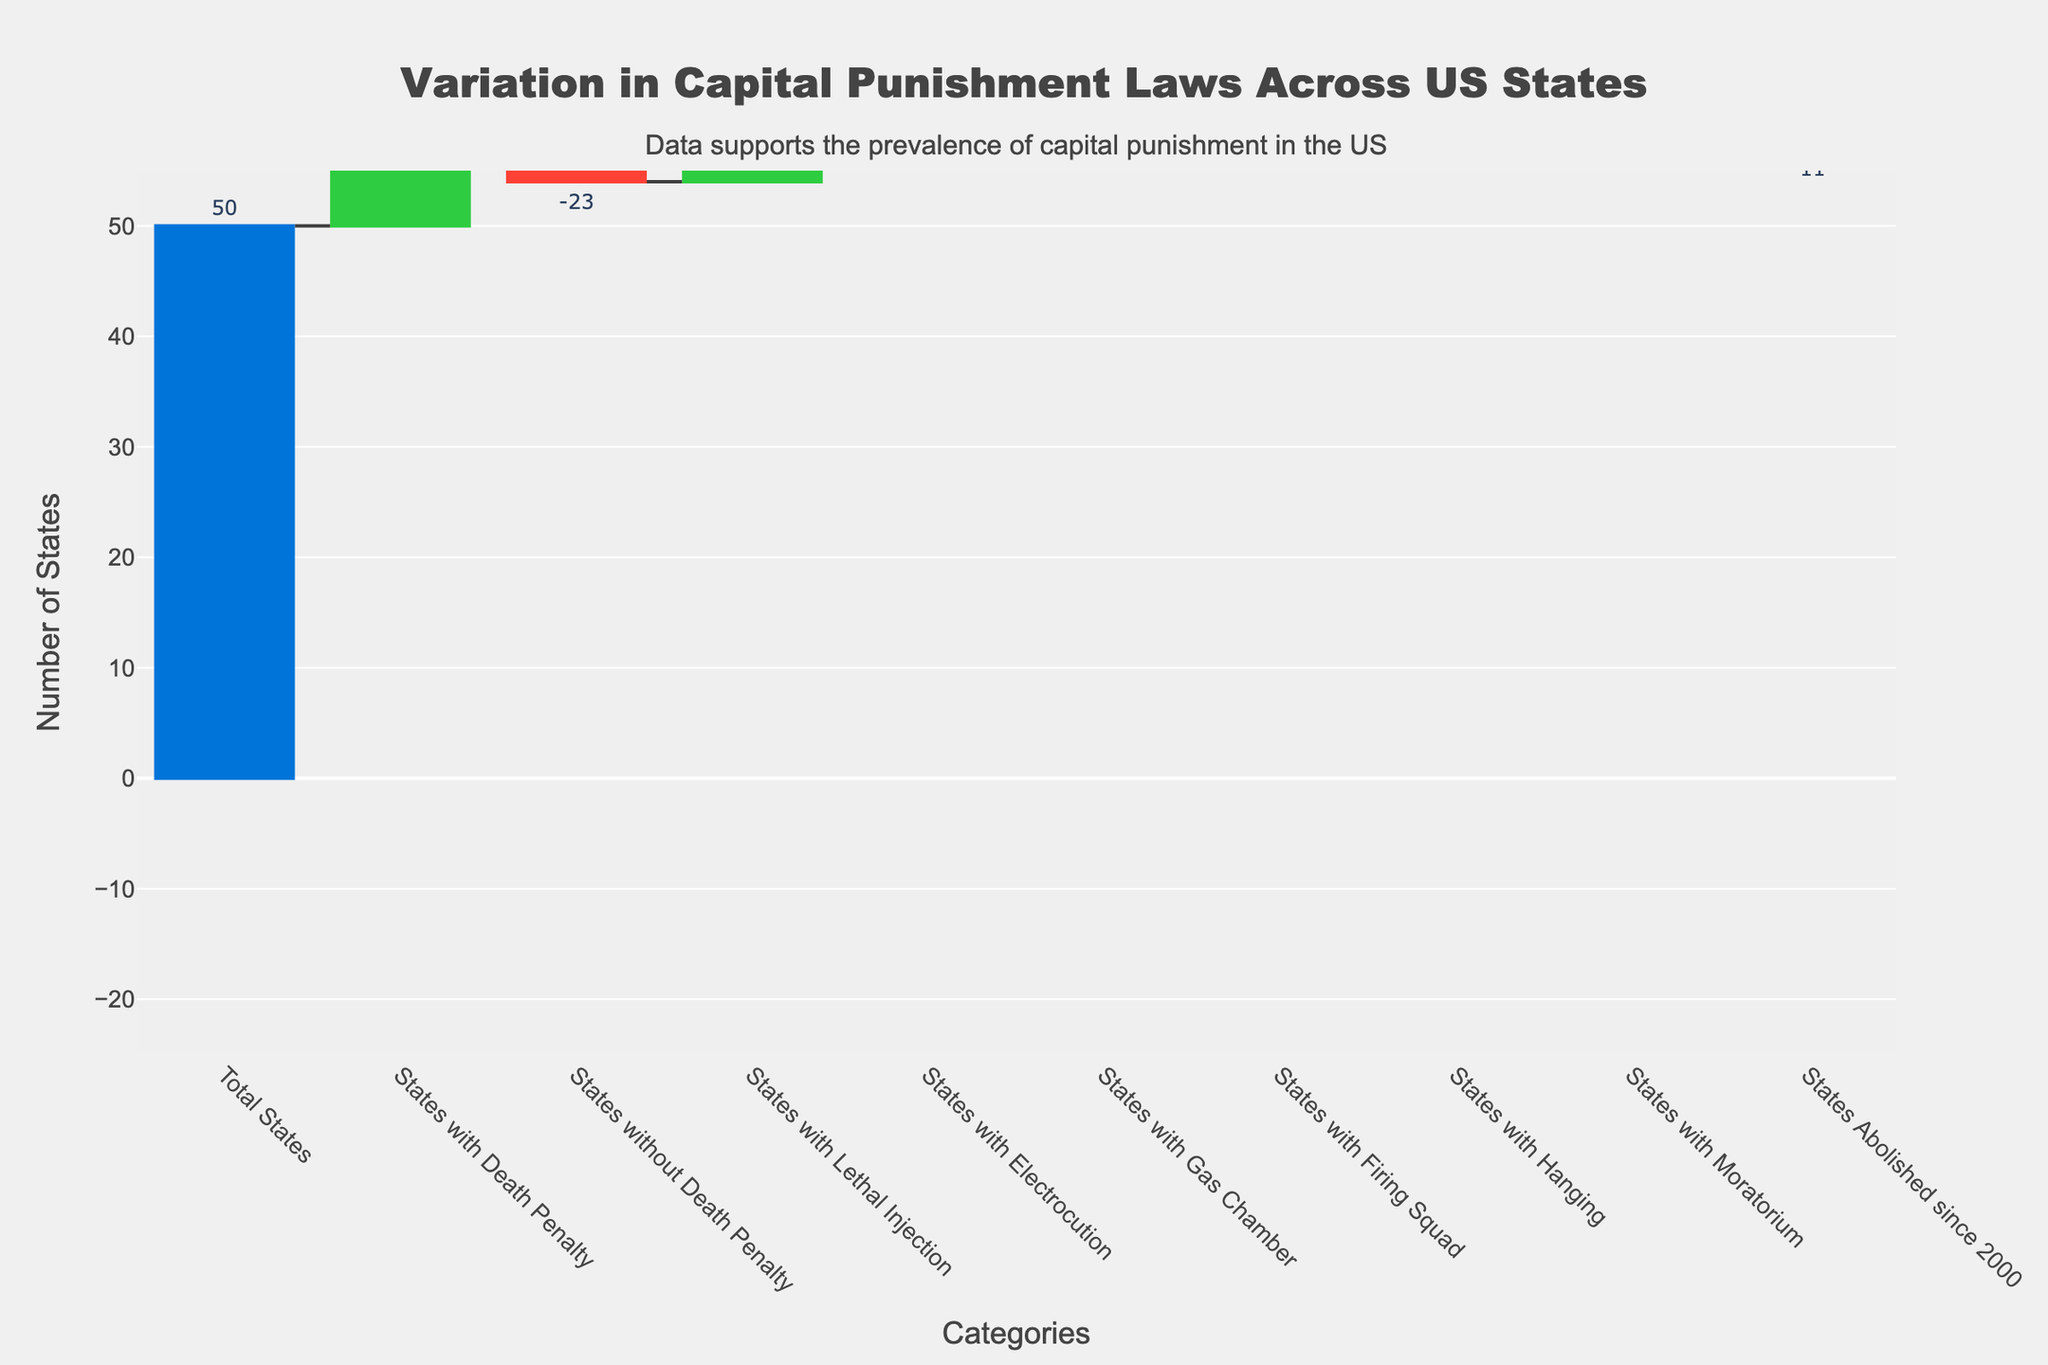What's the total number of states analyzed in the chart? The title and the first category data indicate that the total number of states analyzed is 50.
Answer: 50 How many states have the death penalty? The category "States with Death Penalty" shows a value of 27, which indicates the number of states with the death penalty.
Answer: 27 What's the number of states that do not have the death penalty? The category "States without Death Penalty" shows a negative value of -23, indicating 23 states do not have the death penalty.
Answer: 23 How many states use lethal injection as a method of execution? The category "States with Lethal Injection" shows a value of 27, indicating that 27 states use lethal injection.
Answer: 27 What is the cumulative change in the number of states by adding the states using electrocution, gas chamber, firing squad, and hanging methods? Adding values from these categories: -2 (electrocution), -3 (gas chamber), -3 (firing squad), -2 (hanging) gives -2 + -3 + -3 + -2 = -10, indicating a decrease of 10 states using these methods.
Answer: -10 How many states have a moratorium on the death penalty? The category "States with Moratorium" shows a value of -3, indicating 3 states have a moratorium on the death penalty.
Answer: 3 How many states have abolished the death penalty since 2000? The category "States Abolished since 2000" shows a value of -11, indicating 11 states have abolished it since 2000.
Answer: 11 What is the overall net change in the number of states regarding death penalty-related policies, considering all categories? Start from the total states (50) and combine the changes for all categories: 50 + (-23) + 27 + (-2) + (-3) + (-3) + (-2) + (-3) + (-11) = 30. Hence, the net change shows a total of 30 states considering all listed policies.
Answer: 30 Based on the categories provided, which execution method is used by the fewest states? The categories "Electrocution," "Gas Chamber," and "Firing Squad" each show a value of -3, indicating the fewest states use these methods.
Answer: Gas Chamber, Firing Squad, Electrocution (tie) Comparing states with the death penalty and states without, which group is larger? The "States with Death Penalty" shows 27 and "States without Death Penalty" shows -23. Since the values indicate the absolute number of states, 27 is larger than 23.
Answer: States with Death Penalty 